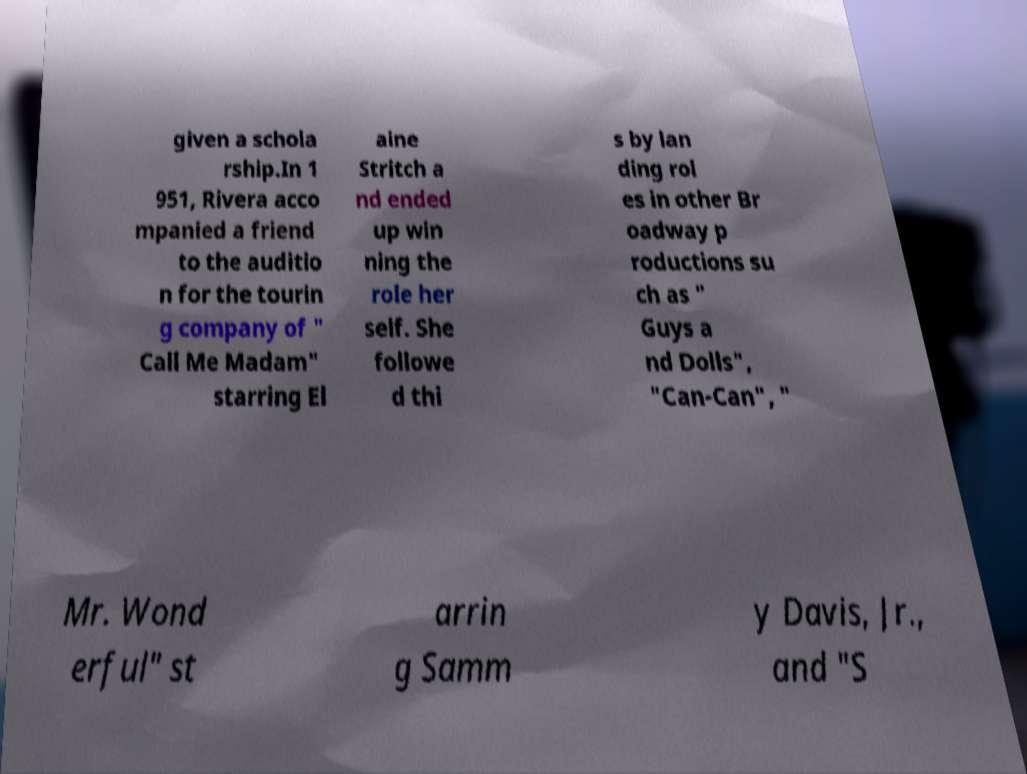What messages or text are displayed in this image? I need them in a readable, typed format. given a schola rship.In 1 951, Rivera acco mpanied a friend to the auditio n for the tourin g company of " Call Me Madam" starring El aine Stritch a nd ended up win ning the role her self. She followe d thi s by lan ding rol es in other Br oadway p roductions su ch as " Guys a nd Dolls", "Can-Can", " Mr. Wond erful" st arrin g Samm y Davis, Jr., and "S 